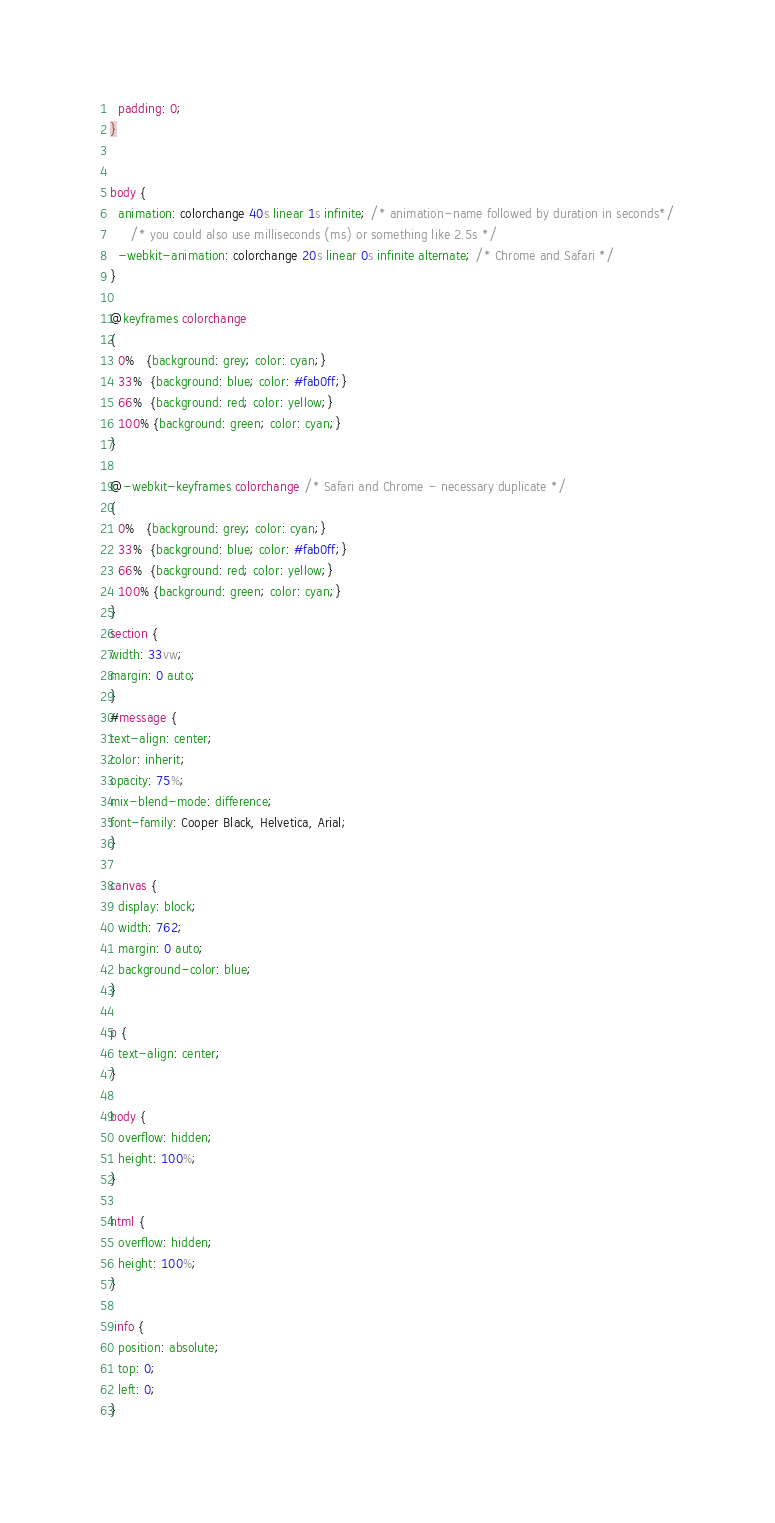Convert code to text. <code><loc_0><loc_0><loc_500><loc_500><_CSS_>  padding: 0;
}


body {
  animation: colorchange 40s linear 1s infinite; /* animation-name followed by duration in seconds*/
     /* you could also use milliseconds (ms) or something like 2.5s */
  -webkit-animation: colorchange 20s linear 0s infinite alternate; /* Chrome and Safari */
}

@keyframes colorchange
{
  0%   {background: grey; color: cyan;}
  33%  {background: blue; color: #fab0ff;}
  66%  {background: red; color: yellow;}
  100% {background: green; color: cyan;}
}

@-webkit-keyframes colorchange /* Safari and Chrome - necessary duplicate */
{
  0%   {background: grey; color: cyan;}
  33%  {background: blue; color: #fab0ff;}
  66%  {background: red; color: yellow;}
  100% {background: green; color: cyan;}
}
section {
width: 33vw;
margin: 0 auto;
}
#message {
text-align: center;
color: inherit;
opacity: 75%;
mix-blend-mode: difference;
font-family: Cooper Black, Helvetica, Arial;
}

canvas {
  display: block;
  width: 762;
  margin: 0 auto;
  background-color: blue;
}

p {
  text-align: center;
}

body {
  overflow: hidden;
  height: 100%;
}

html {
  overflow: hidden;
  height: 100%;
}

.info {
  position: absolute;
  top: 0;
  left: 0;
}
</code> 